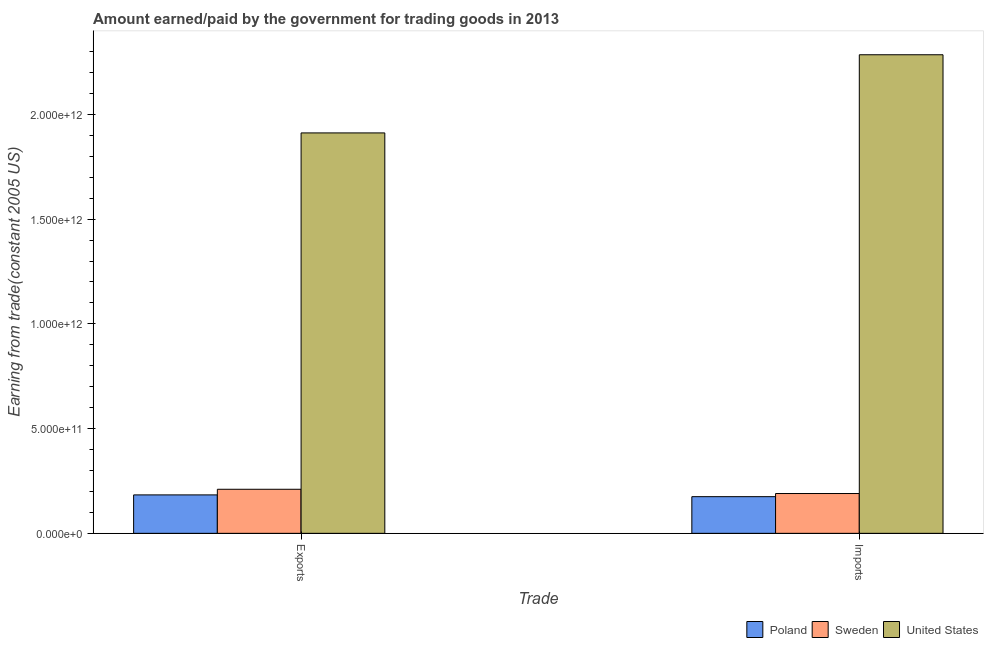How many different coloured bars are there?
Your answer should be very brief. 3. How many groups of bars are there?
Provide a short and direct response. 2. How many bars are there on the 1st tick from the left?
Make the answer very short. 3. How many bars are there on the 2nd tick from the right?
Make the answer very short. 3. What is the label of the 2nd group of bars from the left?
Keep it short and to the point. Imports. What is the amount earned from exports in Sweden?
Provide a succinct answer. 2.10e+11. Across all countries, what is the maximum amount paid for imports?
Give a very brief answer. 2.28e+12. Across all countries, what is the minimum amount paid for imports?
Your response must be concise. 1.75e+11. What is the total amount earned from exports in the graph?
Provide a succinct answer. 2.31e+12. What is the difference between the amount earned from exports in Sweden and that in Poland?
Offer a very short reply. 2.68e+1. What is the difference between the amount earned from exports in Sweden and the amount paid for imports in United States?
Give a very brief answer. -2.07e+12. What is the average amount earned from exports per country?
Make the answer very short. 7.68e+11. What is the difference between the amount earned from exports and amount paid for imports in United States?
Provide a short and direct response. -3.73e+11. What is the ratio of the amount paid for imports in United States to that in Poland?
Keep it short and to the point. 13.05. What does the 3rd bar from the left in Imports represents?
Your answer should be compact. United States. What is the difference between two consecutive major ticks on the Y-axis?
Provide a succinct answer. 5.00e+11. Are the values on the major ticks of Y-axis written in scientific E-notation?
Ensure brevity in your answer.  Yes. Does the graph contain any zero values?
Provide a succinct answer. No. How many legend labels are there?
Offer a terse response. 3. How are the legend labels stacked?
Offer a terse response. Horizontal. What is the title of the graph?
Give a very brief answer. Amount earned/paid by the government for trading goods in 2013. Does "Cayman Islands" appear as one of the legend labels in the graph?
Make the answer very short. No. What is the label or title of the X-axis?
Give a very brief answer. Trade. What is the label or title of the Y-axis?
Your response must be concise. Earning from trade(constant 2005 US). What is the Earning from trade(constant 2005 US) of Poland in Exports?
Keep it short and to the point. 1.83e+11. What is the Earning from trade(constant 2005 US) of Sweden in Exports?
Offer a terse response. 2.10e+11. What is the Earning from trade(constant 2005 US) in United States in Exports?
Keep it short and to the point. 1.91e+12. What is the Earning from trade(constant 2005 US) of Poland in Imports?
Your response must be concise. 1.75e+11. What is the Earning from trade(constant 2005 US) of Sweden in Imports?
Offer a terse response. 1.90e+11. What is the Earning from trade(constant 2005 US) in United States in Imports?
Give a very brief answer. 2.28e+12. Across all Trade, what is the maximum Earning from trade(constant 2005 US) in Poland?
Your answer should be very brief. 1.83e+11. Across all Trade, what is the maximum Earning from trade(constant 2005 US) of Sweden?
Provide a succinct answer. 2.10e+11. Across all Trade, what is the maximum Earning from trade(constant 2005 US) in United States?
Offer a very short reply. 2.28e+12. Across all Trade, what is the minimum Earning from trade(constant 2005 US) of Poland?
Keep it short and to the point. 1.75e+11. Across all Trade, what is the minimum Earning from trade(constant 2005 US) of Sweden?
Keep it short and to the point. 1.90e+11. Across all Trade, what is the minimum Earning from trade(constant 2005 US) in United States?
Provide a succinct answer. 1.91e+12. What is the total Earning from trade(constant 2005 US) in Poland in the graph?
Your answer should be very brief. 3.59e+11. What is the total Earning from trade(constant 2005 US) in Sweden in the graph?
Offer a terse response. 4.00e+11. What is the total Earning from trade(constant 2005 US) of United States in the graph?
Offer a very short reply. 4.20e+12. What is the difference between the Earning from trade(constant 2005 US) of Poland in Exports and that in Imports?
Offer a very short reply. 8.41e+09. What is the difference between the Earning from trade(constant 2005 US) of Sweden in Exports and that in Imports?
Your response must be concise. 2.03e+1. What is the difference between the Earning from trade(constant 2005 US) of United States in Exports and that in Imports?
Ensure brevity in your answer.  -3.73e+11. What is the difference between the Earning from trade(constant 2005 US) in Poland in Exports and the Earning from trade(constant 2005 US) in Sweden in Imports?
Your answer should be compact. -6.56e+09. What is the difference between the Earning from trade(constant 2005 US) in Poland in Exports and the Earning from trade(constant 2005 US) in United States in Imports?
Provide a succinct answer. -2.10e+12. What is the difference between the Earning from trade(constant 2005 US) of Sweden in Exports and the Earning from trade(constant 2005 US) of United States in Imports?
Provide a succinct answer. -2.07e+12. What is the average Earning from trade(constant 2005 US) in Poland per Trade?
Offer a very short reply. 1.79e+11. What is the average Earning from trade(constant 2005 US) in Sweden per Trade?
Give a very brief answer. 2.00e+11. What is the average Earning from trade(constant 2005 US) of United States per Trade?
Ensure brevity in your answer.  2.10e+12. What is the difference between the Earning from trade(constant 2005 US) of Poland and Earning from trade(constant 2005 US) of Sweden in Exports?
Provide a short and direct response. -2.68e+1. What is the difference between the Earning from trade(constant 2005 US) in Poland and Earning from trade(constant 2005 US) in United States in Exports?
Your answer should be compact. -1.73e+12. What is the difference between the Earning from trade(constant 2005 US) in Sweden and Earning from trade(constant 2005 US) in United States in Exports?
Your answer should be very brief. -1.70e+12. What is the difference between the Earning from trade(constant 2005 US) in Poland and Earning from trade(constant 2005 US) in Sweden in Imports?
Make the answer very short. -1.50e+1. What is the difference between the Earning from trade(constant 2005 US) in Poland and Earning from trade(constant 2005 US) in United States in Imports?
Keep it short and to the point. -2.11e+12. What is the difference between the Earning from trade(constant 2005 US) in Sweden and Earning from trade(constant 2005 US) in United States in Imports?
Provide a short and direct response. -2.09e+12. What is the ratio of the Earning from trade(constant 2005 US) in Poland in Exports to that in Imports?
Your response must be concise. 1.05. What is the ratio of the Earning from trade(constant 2005 US) in Sweden in Exports to that in Imports?
Provide a succinct answer. 1.11. What is the ratio of the Earning from trade(constant 2005 US) of United States in Exports to that in Imports?
Provide a succinct answer. 0.84. What is the difference between the highest and the second highest Earning from trade(constant 2005 US) in Poland?
Your response must be concise. 8.41e+09. What is the difference between the highest and the second highest Earning from trade(constant 2005 US) in Sweden?
Keep it short and to the point. 2.03e+1. What is the difference between the highest and the second highest Earning from trade(constant 2005 US) of United States?
Your response must be concise. 3.73e+11. What is the difference between the highest and the lowest Earning from trade(constant 2005 US) of Poland?
Offer a terse response. 8.41e+09. What is the difference between the highest and the lowest Earning from trade(constant 2005 US) of Sweden?
Make the answer very short. 2.03e+1. What is the difference between the highest and the lowest Earning from trade(constant 2005 US) of United States?
Make the answer very short. 3.73e+11. 